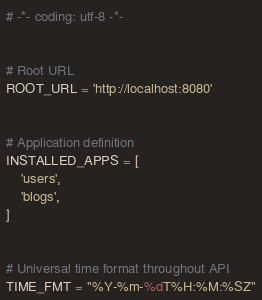<code> <loc_0><loc_0><loc_500><loc_500><_Python_># -*- coding: utf-8 -*-


# Root URL
ROOT_URL = 'http://localhost:8080'


# Application definition
INSTALLED_APPS = [
    'users',
    'blogs',
]


# Universal time format throughout API
TIME_FMT = "%Y-%m-%dT%H:%M:%SZ"
</code> 